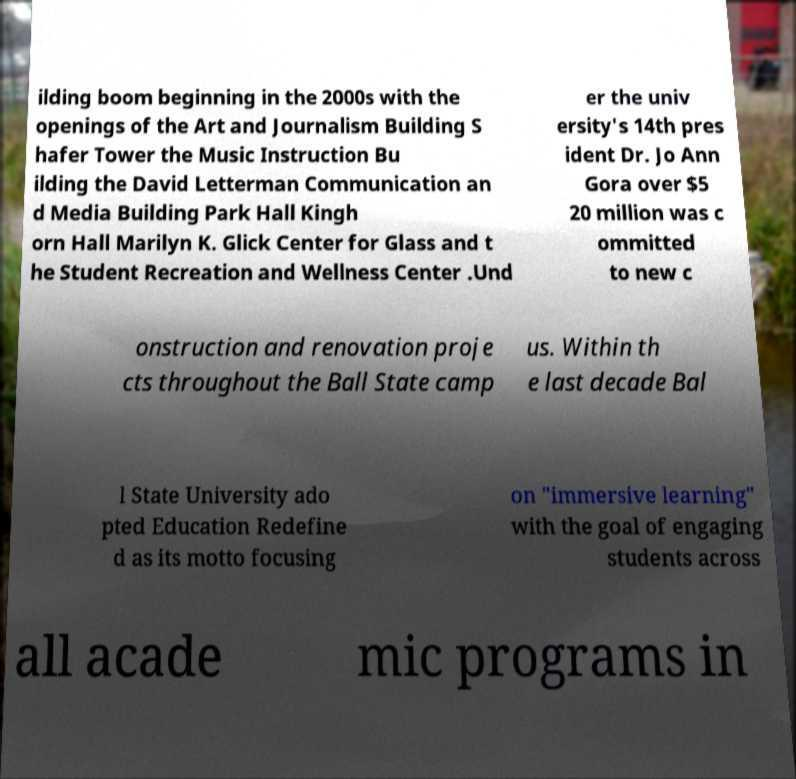For documentation purposes, I need the text within this image transcribed. Could you provide that? ilding boom beginning in the 2000s with the openings of the Art and Journalism Building S hafer Tower the Music Instruction Bu ilding the David Letterman Communication an d Media Building Park Hall Kingh orn Hall Marilyn K. Glick Center for Glass and t he Student Recreation and Wellness Center .Und er the univ ersity's 14th pres ident Dr. Jo Ann Gora over $5 20 million was c ommitted to new c onstruction and renovation proje cts throughout the Ball State camp us. Within th e last decade Bal l State University ado pted Education Redefine d as its motto focusing on "immersive learning" with the goal of engaging students across all acade mic programs in 